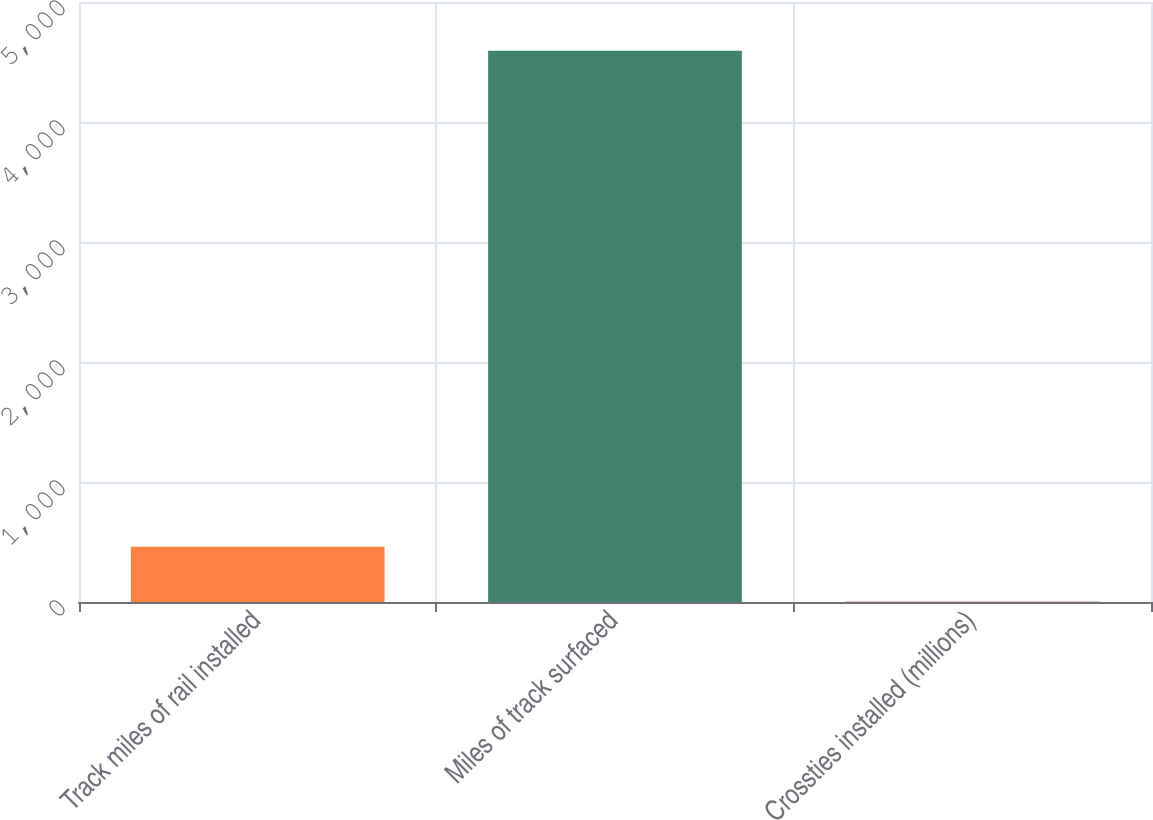Convert chart to OTSL. <chart><loc_0><loc_0><loc_500><loc_500><bar_chart><fcel>Track miles of rail installed<fcel>Miles of track surfaced<fcel>Crossties installed (millions)<nl><fcel>461.38<fcel>4594<fcel>2.2<nl></chart> 